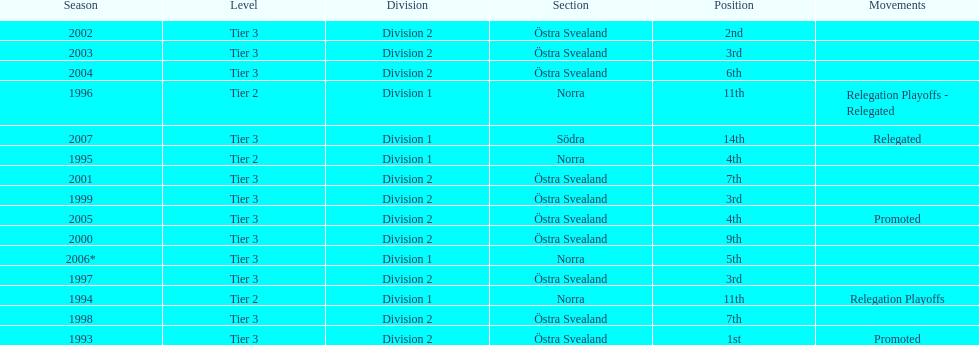Which year was more successful, 2007 or 2002? 2002. 